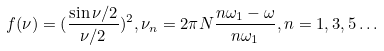<formula> <loc_0><loc_0><loc_500><loc_500>f ( \nu ) = ( \frac { \sin \nu / 2 } { \nu / 2 } ) ^ { 2 } , \nu _ { n } = 2 \pi N \frac { n \omega _ { 1 } - \omega } { n \omega _ { 1 } } , n = 1 , 3 , 5 \dots</formula> 